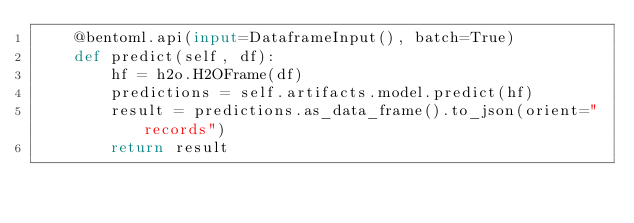Convert code to text. <code><loc_0><loc_0><loc_500><loc_500><_Python_>    @bentoml.api(input=DataframeInput(), batch=True)
    def predict(self, df):
        hf = h2o.H2OFrame(df)
        predictions = self.artifacts.model.predict(hf)
        result = predictions.as_data_frame().to_json(orient="records")
        return result
</code> 